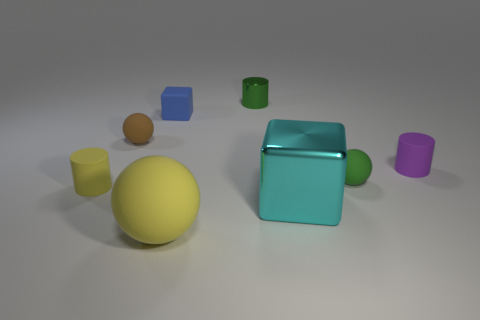Are there more metal objects than rubber blocks?
Your response must be concise. Yes. What is the color of the large ball that is in front of the yellow thing that is on the left side of the matte sphere behind the small purple cylinder?
Provide a succinct answer. Yellow. There is a green thing that is to the left of the big cyan metallic thing; is it the same shape as the purple object?
Offer a terse response. Yes. What color is the metal cylinder that is the same size as the rubber block?
Give a very brief answer. Green. How many green cylinders are there?
Offer a very short reply. 1. Is the material of the small cylinder that is to the left of the small blue matte block the same as the green cylinder?
Ensure brevity in your answer.  No. What is the cylinder that is in front of the green metallic cylinder and left of the large cyan block made of?
Your answer should be compact. Rubber. What is the size of the sphere that is the same color as the tiny metallic thing?
Offer a very short reply. Small. The small sphere that is to the left of the green object that is on the right side of the tiny metallic cylinder is made of what material?
Keep it short and to the point. Rubber. How big is the yellow object that is in front of the tiny cylinder left of the tiny matte thing behind the brown thing?
Keep it short and to the point. Large. 